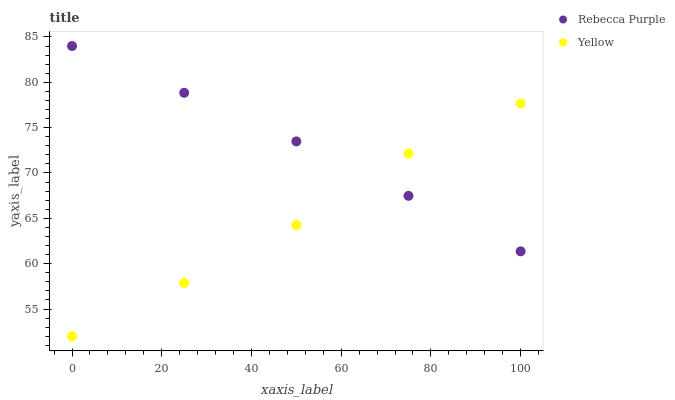Does Yellow have the minimum area under the curve?
Answer yes or no. Yes. Does Rebecca Purple have the maximum area under the curve?
Answer yes or no. Yes. Does Yellow have the maximum area under the curve?
Answer yes or no. No. Is Rebecca Purple the smoothest?
Answer yes or no. Yes. Is Yellow the roughest?
Answer yes or no. Yes. Is Yellow the smoothest?
Answer yes or no. No. Does Yellow have the lowest value?
Answer yes or no. Yes. Does Rebecca Purple have the highest value?
Answer yes or no. Yes. Does Yellow have the highest value?
Answer yes or no. No. Does Yellow intersect Rebecca Purple?
Answer yes or no. Yes. Is Yellow less than Rebecca Purple?
Answer yes or no. No. Is Yellow greater than Rebecca Purple?
Answer yes or no. No. 